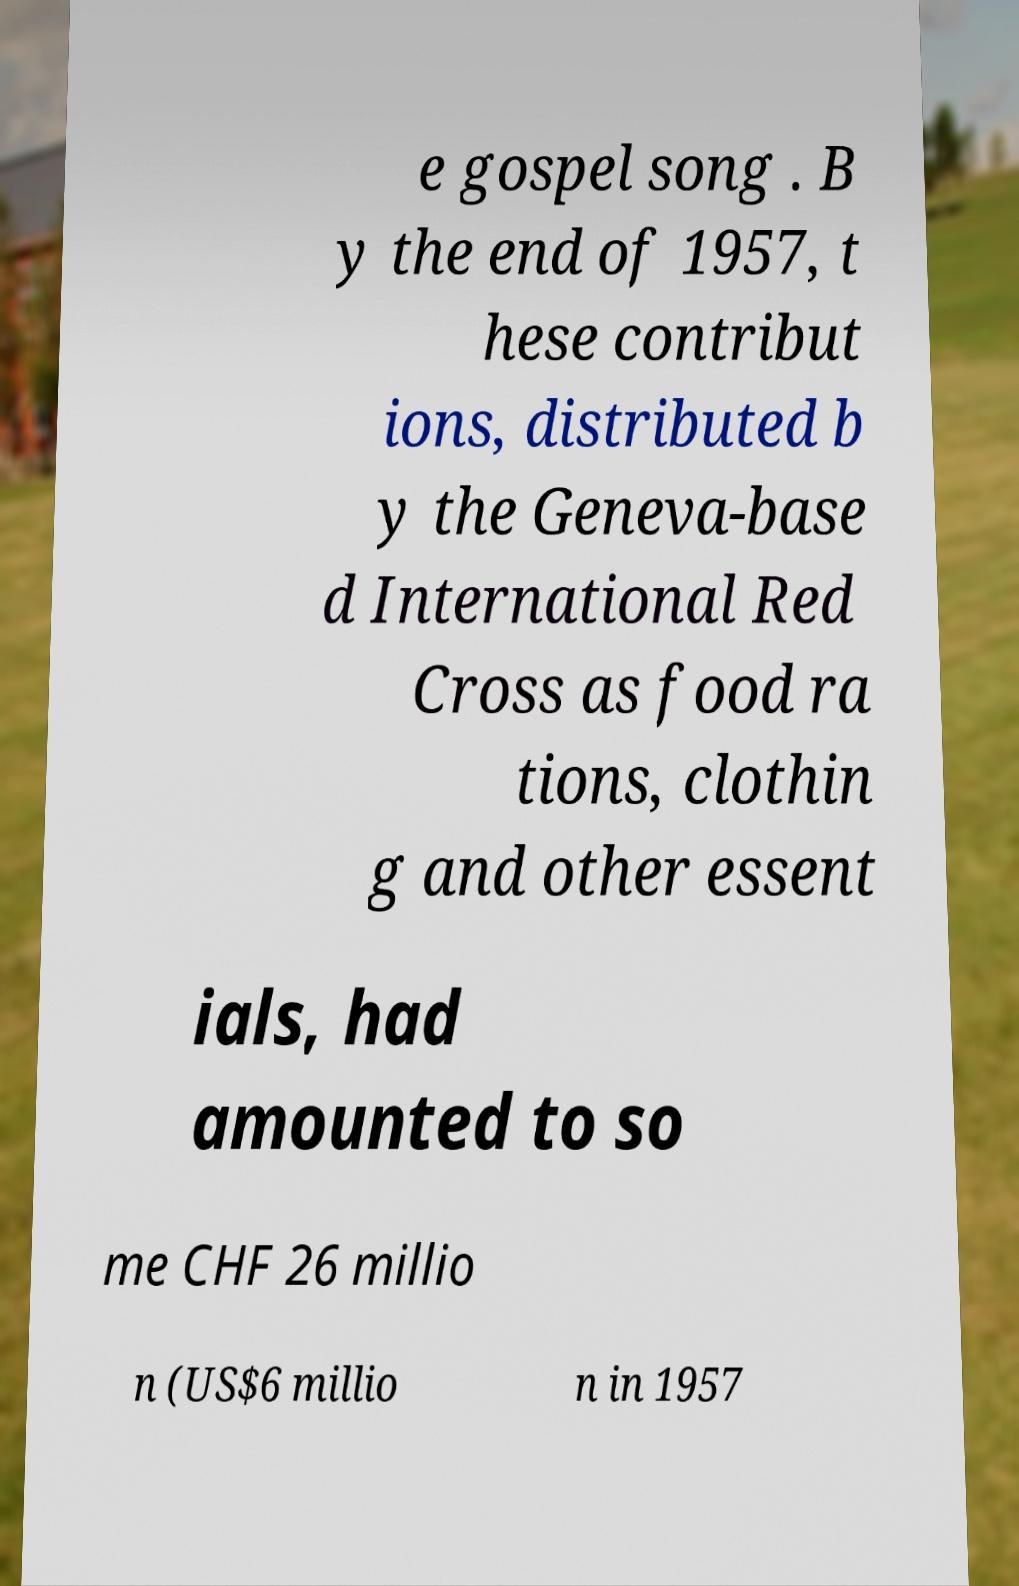For documentation purposes, I need the text within this image transcribed. Could you provide that? e gospel song . B y the end of 1957, t hese contribut ions, distributed b y the Geneva-base d International Red Cross as food ra tions, clothin g and other essent ials, had amounted to so me CHF 26 millio n (US$6 millio n in 1957 